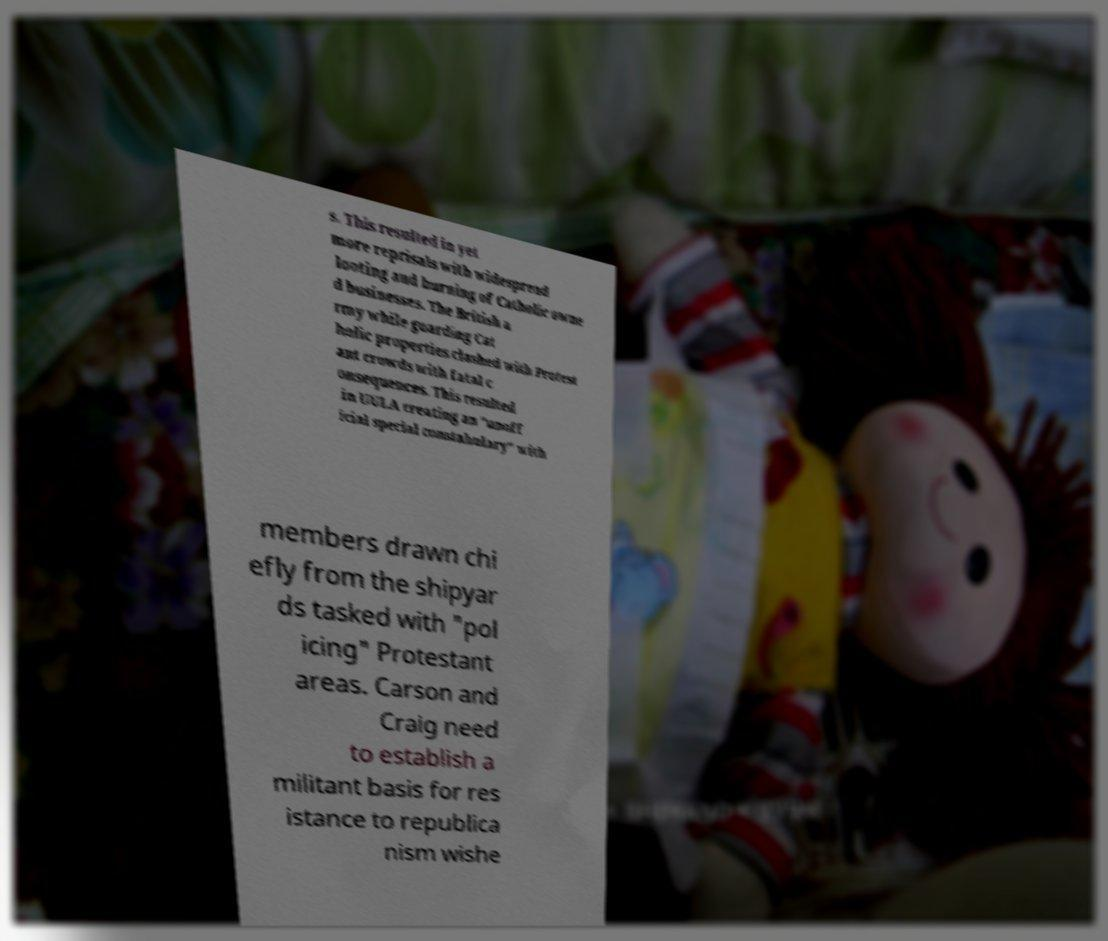Could you assist in decoding the text presented in this image and type it out clearly? s. This resulted in yet more reprisals with widespread looting and burning of Catholic owne d businesses. The British a rmy while guarding Cat holic properties clashed with Protest ant crowds with fatal c onsequences. This resulted in UULA creating an "unoff icial special constabulary" with members drawn chi efly from the shipyar ds tasked with "pol icing" Protestant areas. Carson and Craig need to establish a militant basis for res istance to republica nism wishe 